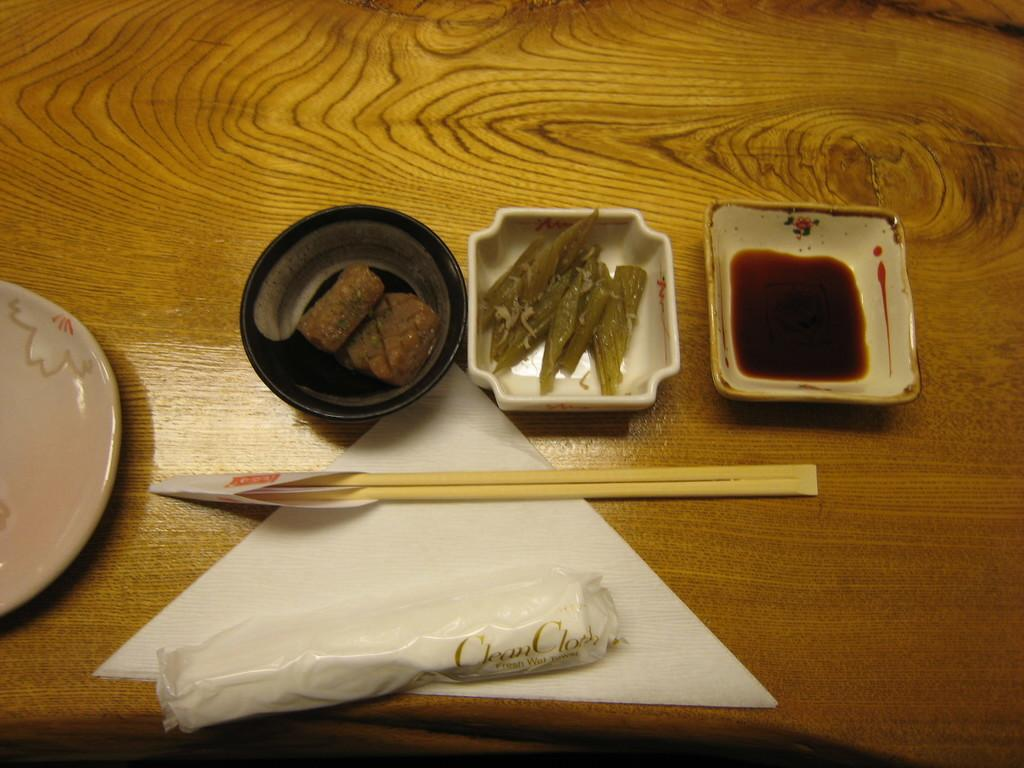What is the main piece of furniture in the image? There is a table in the image. How many bowls are on the table? There are multiple bowls on the table. Are there any other dishes on the table besides the bowls? Yes, there is at least one plate on the table. What is inside the bowls? The bowls contain food items. What item is present on the table for cleaning or wiping? There is a tissue on the table. What utensils are on the table? There are chopsticks on the table. How many friends are laughing in the image? There are no friends or laughter depicted in the image; it only shows a table with bowls, a plate, a tissue, and chopsticks. 